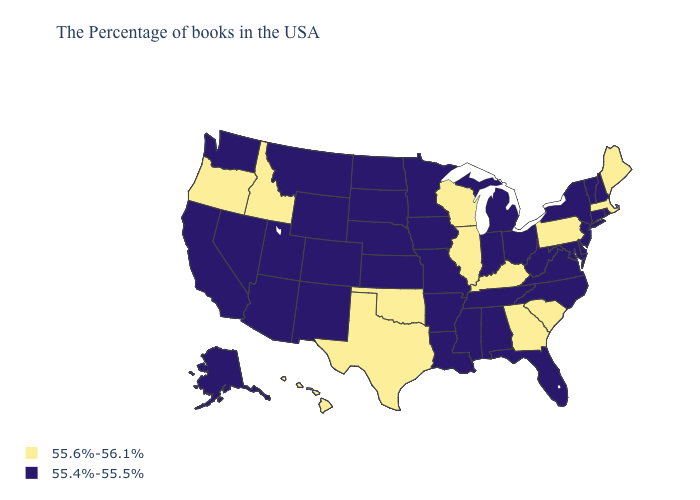Name the states that have a value in the range 55.6%-56.1%?
Be succinct. Maine, Massachusetts, Pennsylvania, South Carolina, Georgia, Kentucky, Wisconsin, Illinois, Oklahoma, Texas, Idaho, Oregon, Hawaii. Among the states that border Texas , does Arkansas have the highest value?
Give a very brief answer. No. Does the first symbol in the legend represent the smallest category?
Concise answer only. No. Does Montana have the same value as South Dakota?
Give a very brief answer. Yes. Does Oregon have the highest value in the USA?
Answer briefly. Yes. Which states have the lowest value in the USA?
Write a very short answer. Rhode Island, New Hampshire, Vermont, Connecticut, New York, New Jersey, Delaware, Maryland, Virginia, North Carolina, West Virginia, Ohio, Florida, Michigan, Indiana, Alabama, Tennessee, Mississippi, Louisiana, Missouri, Arkansas, Minnesota, Iowa, Kansas, Nebraska, South Dakota, North Dakota, Wyoming, Colorado, New Mexico, Utah, Montana, Arizona, Nevada, California, Washington, Alaska. What is the highest value in states that border Wisconsin?
Give a very brief answer. 55.6%-56.1%. Does the first symbol in the legend represent the smallest category?
Be succinct. No. What is the value of New York?
Answer briefly. 55.4%-55.5%. What is the lowest value in states that border Montana?
Be succinct. 55.4%-55.5%. What is the value of Pennsylvania?
Be succinct. 55.6%-56.1%. Does South Carolina have a lower value than New York?
Concise answer only. No. What is the value of Louisiana?
Write a very short answer. 55.4%-55.5%. What is the lowest value in states that border Montana?
Quick response, please. 55.4%-55.5%. Does Idaho have the lowest value in the USA?
Concise answer only. No. 